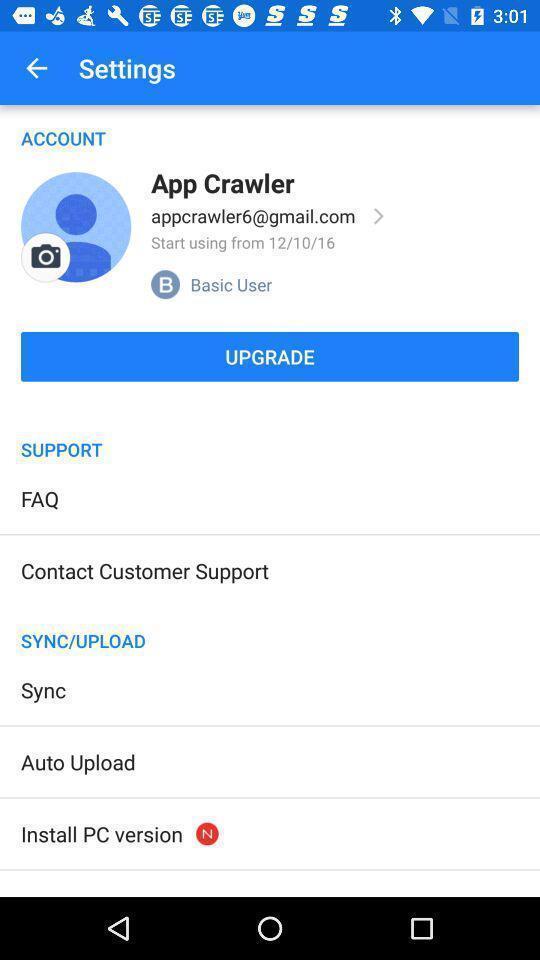Please provide a description for this image. Page showing different setting options on an app. 